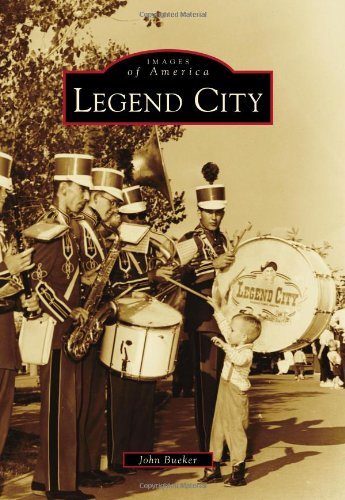Who is the author of this book? John Bueker is the credited author of 'Legend City,' a notable work exploring the intriguing historical themes of an American theme park. 